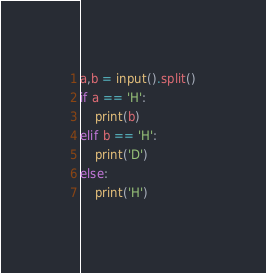<code> <loc_0><loc_0><loc_500><loc_500><_Python_>a,b = input().split()
if a == 'H':
    print(b)
elif b == 'H':
    print('D')
else:
    print('H')</code> 